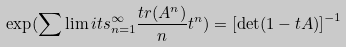<formula> <loc_0><loc_0><loc_500><loc_500>\exp ( \sum \lim i t s _ { n = 1 } ^ { \infty } \frac { t r ( A ^ { n } ) } { n } t ^ { n } ) = \left [ \det ( 1 - t A ) \right ] ^ { - 1 }</formula> 